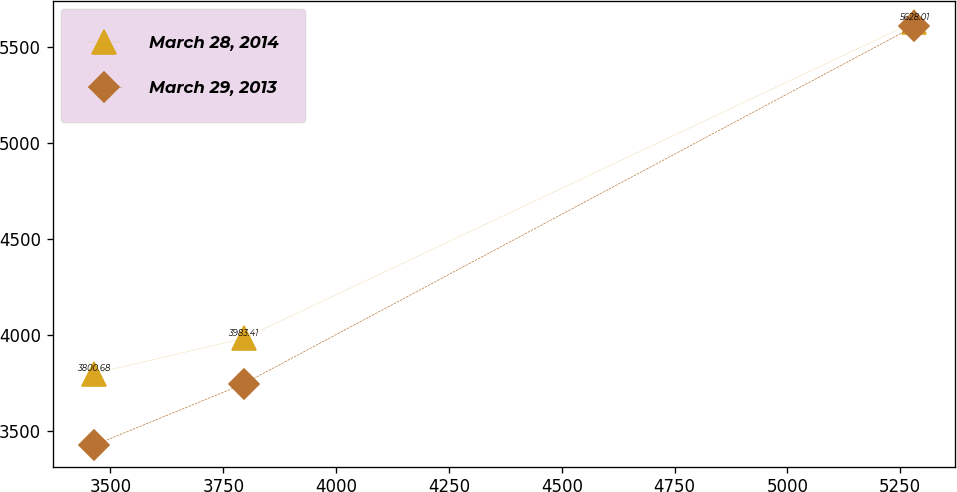Convert chart to OTSL. <chart><loc_0><loc_0><loc_500><loc_500><line_chart><ecel><fcel>March 28, 2014<fcel>March 29, 2013<nl><fcel>3462.85<fcel>3800.68<fcel>3426.91<nl><fcel>3795.1<fcel>3983.41<fcel>3746.89<nl><fcel>5280.54<fcel>5628.01<fcel>5605.01<nl></chart> 